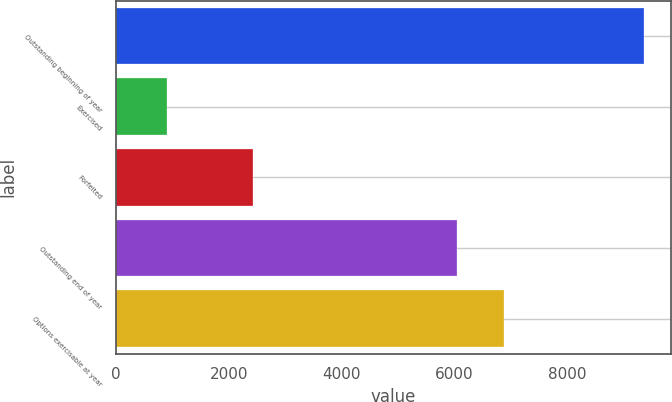<chart> <loc_0><loc_0><loc_500><loc_500><bar_chart><fcel>Outstanding beginning of year<fcel>Exercised<fcel>Forfeited<fcel>Outstanding end of year<fcel>Options exercisable at year<nl><fcel>9370<fcel>904<fcel>2426<fcel>6040<fcel>6886.6<nl></chart> 